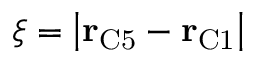Convert formula to latex. <formula><loc_0><loc_0><loc_500><loc_500>\xi = \left | r _ { C 5 } - r _ { C 1 } \right |</formula> 